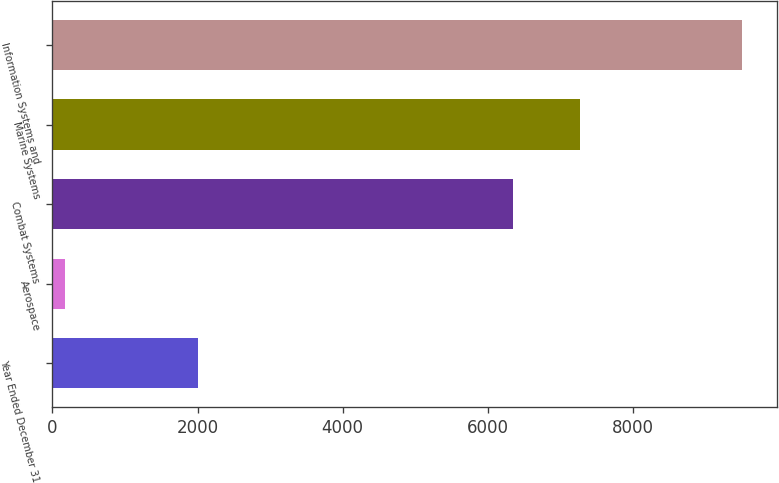Convert chart to OTSL. <chart><loc_0><loc_0><loc_500><loc_500><bar_chart><fcel>Year Ended December 31<fcel>Aerospace<fcel>Combat Systems<fcel>Marine Systems<fcel>Information Systems and<nl><fcel>2011<fcel>171<fcel>6343<fcel>7276.6<fcel>9507<nl></chart> 